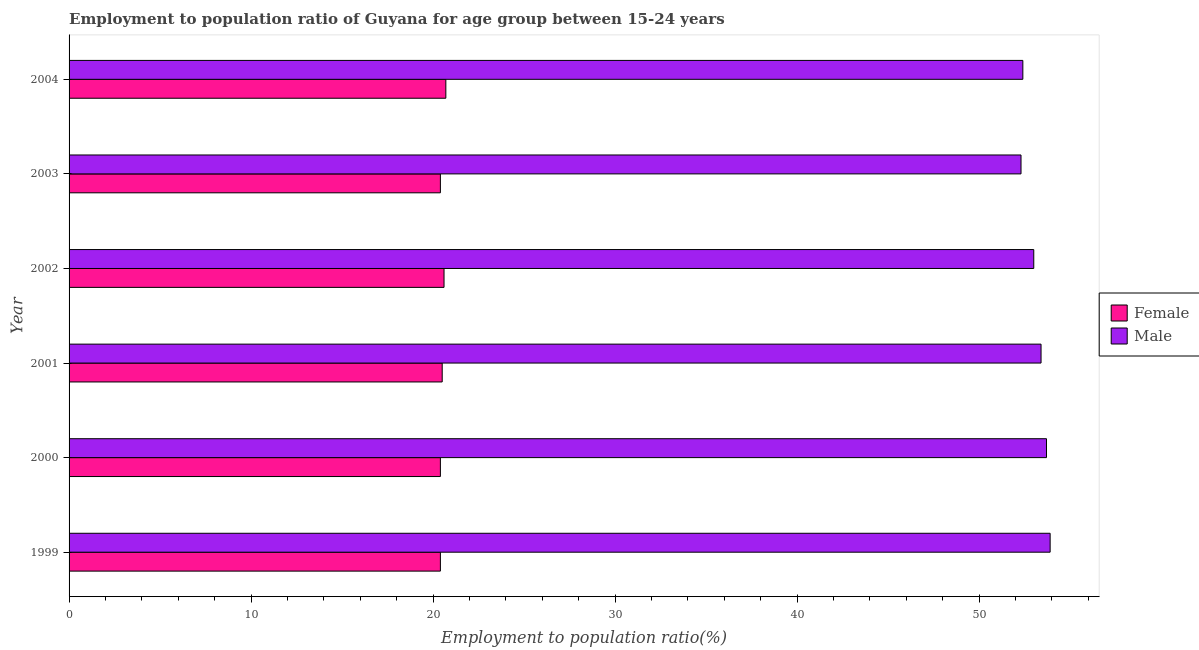Are the number of bars per tick equal to the number of legend labels?
Offer a very short reply. Yes. How many bars are there on the 3rd tick from the top?
Make the answer very short. 2. How many bars are there on the 1st tick from the bottom?
Your answer should be compact. 2. What is the label of the 1st group of bars from the top?
Offer a very short reply. 2004. In how many cases, is the number of bars for a given year not equal to the number of legend labels?
Offer a terse response. 0. What is the employment to population ratio(male) in 2002?
Your answer should be compact. 53. Across all years, what is the maximum employment to population ratio(male)?
Your answer should be very brief. 53.9. Across all years, what is the minimum employment to population ratio(female)?
Your answer should be compact. 20.4. In which year was the employment to population ratio(male) maximum?
Make the answer very short. 1999. What is the total employment to population ratio(male) in the graph?
Ensure brevity in your answer.  318.7. What is the difference between the employment to population ratio(female) in 1999 and that in 2002?
Your answer should be compact. -0.2. What is the difference between the employment to population ratio(female) in 1999 and the employment to population ratio(male) in 2001?
Your response must be concise. -33. What is the average employment to population ratio(female) per year?
Provide a short and direct response. 20.5. In the year 2004, what is the difference between the employment to population ratio(male) and employment to population ratio(female)?
Your response must be concise. 31.7. What is the ratio of the employment to population ratio(male) in 2003 to that in 2004?
Give a very brief answer. 1. Is the employment to population ratio(female) in 2000 less than that in 2001?
Offer a very short reply. Yes. Is the difference between the employment to population ratio(female) in 2001 and 2004 greater than the difference between the employment to population ratio(male) in 2001 and 2004?
Your answer should be compact. No. What is the difference between the highest and the lowest employment to population ratio(male)?
Your response must be concise. 1.6. In how many years, is the employment to population ratio(male) greater than the average employment to population ratio(male) taken over all years?
Keep it short and to the point. 3. What does the 1st bar from the bottom in 2002 represents?
Your response must be concise. Female. Are all the bars in the graph horizontal?
Offer a terse response. Yes. How many years are there in the graph?
Your answer should be compact. 6. Are the values on the major ticks of X-axis written in scientific E-notation?
Offer a very short reply. No. Does the graph contain grids?
Offer a very short reply. No. Where does the legend appear in the graph?
Make the answer very short. Center right. How many legend labels are there?
Your answer should be compact. 2. How are the legend labels stacked?
Make the answer very short. Vertical. What is the title of the graph?
Make the answer very short. Employment to population ratio of Guyana for age group between 15-24 years. What is the label or title of the X-axis?
Give a very brief answer. Employment to population ratio(%). What is the label or title of the Y-axis?
Your answer should be compact. Year. What is the Employment to population ratio(%) in Female in 1999?
Give a very brief answer. 20.4. What is the Employment to population ratio(%) in Male in 1999?
Keep it short and to the point. 53.9. What is the Employment to population ratio(%) of Female in 2000?
Your response must be concise. 20.4. What is the Employment to population ratio(%) of Male in 2000?
Your answer should be compact. 53.7. What is the Employment to population ratio(%) of Male in 2001?
Give a very brief answer. 53.4. What is the Employment to population ratio(%) in Female in 2002?
Keep it short and to the point. 20.6. What is the Employment to population ratio(%) in Male in 2002?
Provide a succinct answer. 53. What is the Employment to population ratio(%) of Female in 2003?
Make the answer very short. 20.4. What is the Employment to population ratio(%) of Male in 2003?
Make the answer very short. 52.3. What is the Employment to population ratio(%) in Female in 2004?
Provide a short and direct response. 20.7. What is the Employment to population ratio(%) in Male in 2004?
Your response must be concise. 52.4. Across all years, what is the maximum Employment to population ratio(%) in Female?
Offer a terse response. 20.7. Across all years, what is the maximum Employment to population ratio(%) of Male?
Ensure brevity in your answer.  53.9. Across all years, what is the minimum Employment to population ratio(%) in Female?
Your answer should be compact. 20.4. Across all years, what is the minimum Employment to population ratio(%) in Male?
Make the answer very short. 52.3. What is the total Employment to population ratio(%) in Female in the graph?
Your answer should be very brief. 123. What is the total Employment to population ratio(%) of Male in the graph?
Offer a very short reply. 318.7. What is the difference between the Employment to population ratio(%) in Female in 1999 and that in 2000?
Give a very brief answer. 0. What is the difference between the Employment to population ratio(%) of Female in 1999 and that in 2001?
Make the answer very short. -0.1. What is the difference between the Employment to population ratio(%) in Male in 1999 and that in 2001?
Offer a terse response. 0.5. What is the difference between the Employment to population ratio(%) in Male in 1999 and that in 2002?
Give a very brief answer. 0.9. What is the difference between the Employment to population ratio(%) of Female in 1999 and that in 2003?
Offer a very short reply. 0. What is the difference between the Employment to population ratio(%) in Male in 1999 and that in 2004?
Provide a succinct answer. 1.5. What is the difference between the Employment to population ratio(%) of Female in 2000 and that in 2001?
Ensure brevity in your answer.  -0.1. What is the difference between the Employment to population ratio(%) in Male in 2000 and that in 2002?
Keep it short and to the point. 0.7. What is the difference between the Employment to population ratio(%) of Female in 2000 and that in 2003?
Provide a succinct answer. 0. What is the difference between the Employment to population ratio(%) in Female in 2000 and that in 2004?
Offer a very short reply. -0.3. What is the difference between the Employment to population ratio(%) of Male in 2001 and that in 2002?
Make the answer very short. 0.4. What is the difference between the Employment to population ratio(%) of Male in 2001 and that in 2003?
Offer a terse response. 1.1. What is the difference between the Employment to population ratio(%) in Female in 2001 and that in 2004?
Your response must be concise. -0.2. What is the difference between the Employment to population ratio(%) in Male in 2001 and that in 2004?
Give a very brief answer. 1. What is the difference between the Employment to population ratio(%) of Female in 2002 and that in 2003?
Your answer should be compact. 0.2. What is the difference between the Employment to population ratio(%) in Male in 2002 and that in 2003?
Ensure brevity in your answer.  0.7. What is the difference between the Employment to population ratio(%) in Male in 2002 and that in 2004?
Provide a short and direct response. 0.6. What is the difference between the Employment to population ratio(%) in Female in 2003 and that in 2004?
Make the answer very short. -0.3. What is the difference between the Employment to population ratio(%) in Female in 1999 and the Employment to population ratio(%) in Male in 2000?
Offer a very short reply. -33.3. What is the difference between the Employment to population ratio(%) in Female in 1999 and the Employment to population ratio(%) in Male in 2001?
Your answer should be compact. -33. What is the difference between the Employment to population ratio(%) in Female in 1999 and the Employment to population ratio(%) in Male in 2002?
Give a very brief answer. -32.6. What is the difference between the Employment to population ratio(%) in Female in 1999 and the Employment to population ratio(%) in Male in 2003?
Provide a succinct answer. -31.9. What is the difference between the Employment to population ratio(%) in Female in 1999 and the Employment to population ratio(%) in Male in 2004?
Make the answer very short. -32. What is the difference between the Employment to population ratio(%) in Female in 2000 and the Employment to population ratio(%) in Male in 2001?
Ensure brevity in your answer.  -33. What is the difference between the Employment to population ratio(%) of Female in 2000 and the Employment to population ratio(%) of Male in 2002?
Ensure brevity in your answer.  -32.6. What is the difference between the Employment to population ratio(%) in Female in 2000 and the Employment to population ratio(%) in Male in 2003?
Offer a very short reply. -31.9. What is the difference between the Employment to population ratio(%) in Female in 2000 and the Employment to population ratio(%) in Male in 2004?
Ensure brevity in your answer.  -32. What is the difference between the Employment to population ratio(%) in Female in 2001 and the Employment to population ratio(%) in Male in 2002?
Keep it short and to the point. -32.5. What is the difference between the Employment to population ratio(%) of Female in 2001 and the Employment to population ratio(%) of Male in 2003?
Keep it short and to the point. -31.8. What is the difference between the Employment to population ratio(%) in Female in 2001 and the Employment to population ratio(%) in Male in 2004?
Provide a succinct answer. -31.9. What is the difference between the Employment to population ratio(%) in Female in 2002 and the Employment to population ratio(%) in Male in 2003?
Your answer should be very brief. -31.7. What is the difference between the Employment to population ratio(%) in Female in 2002 and the Employment to population ratio(%) in Male in 2004?
Your answer should be compact. -31.8. What is the difference between the Employment to population ratio(%) of Female in 2003 and the Employment to population ratio(%) of Male in 2004?
Your answer should be compact. -32. What is the average Employment to population ratio(%) in Female per year?
Ensure brevity in your answer.  20.5. What is the average Employment to population ratio(%) of Male per year?
Ensure brevity in your answer.  53.12. In the year 1999, what is the difference between the Employment to population ratio(%) of Female and Employment to population ratio(%) of Male?
Your answer should be compact. -33.5. In the year 2000, what is the difference between the Employment to population ratio(%) of Female and Employment to population ratio(%) of Male?
Offer a terse response. -33.3. In the year 2001, what is the difference between the Employment to population ratio(%) in Female and Employment to population ratio(%) in Male?
Offer a very short reply. -32.9. In the year 2002, what is the difference between the Employment to population ratio(%) of Female and Employment to population ratio(%) of Male?
Your answer should be compact. -32.4. In the year 2003, what is the difference between the Employment to population ratio(%) in Female and Employment to population ratio(%) in Male?
Your response must be concise. -31.9. In the year 2004, what is the difference between the Employment to population ratio(%) in Female and Employment to population ratio(%) in Male?
Make the answer very short. -31.7. What is the ratio of the Employment to population ratio(%) in Male in 1999 to that in 2000?
Give a very brief answer. 1. What is the ratio of the Employment to population ratio(%) in Female in 1999 to that in 2001?
Ensure brevity in your answer.  1. What is the ratio of the Employment to population ratio(%) in Male in 1999 to that in 2001?
Your answer should be very brief. 1.01. What is the ratio of the Employment to population ratio(%) of Female in 1999 to that in 2002?
Offer a very short reply. 0.99. What is the ratio of the Employment to population ratio(%) of Male in 1999 to that in 2002?
Provide a succinct answer. 1.02. What is the ratio of the Employment to population ratio(%) in Female in 1999 to that in 2003?
Ensure brevity in your answer.  1. What is the ratio of the Employment to population ratio(%) of Male in 1999 to that in 2003?
Your answer should be very brief. 1.03. What is the ratio of the Employment to population ratio(%) of Female in 1999 to that in 2004?
Give a very brief answer. 0.99. What is the ratio of the Employment to population ratio(%) of Male in 1999 to that in 2004?
Offer a very short reply. 1.03. What is the ratio of the Employment to population ratio(%) in Male in 2000 to that in 2001?
Offer a very short reply. 1.01. What is the ratio of the Employment to population ratio(%) of Female in 2000 to that in 2002?
Provide a succinct answer. 0.99. What is the ratio of the Employment to population ratio(%) in Male in 2000 to that in 2002?
Offer a terse response. 1.01. What is the ratio of the Employment to population ratio(%) of Female in 2000 to that in 2003?
Your answer should be compact. 1. What is the ratio of the Employment to population ratio(%) of Male in 2000 to that in 2003?
Your answer should be very brief. 1.03. What is the ratio of the Employment to population ratio(%) in Female in 2000 to that in 2004?
Keep it short and to the point. 0.99. What is the ratio of the Employment to population ratio(%) of Male in 2000 to that in 2004?
Ensure brevity in your answer.  1.02. What is the ratio of the Employment to population ratio(%) of Female in 2001 to that in 2002?
Your response must be concise. 1. What is the ratio of the Employment to population ratio(%) in Male in 2001 to that in 2002?
Make the answer very short. 1.01. What is the ratio of the Employment to population ratio(%) in Female in 2001 to that in 2003?
Your response must be concise. 1. What is the ratio of the Employment to population ratio(%) of Male in 2001 to that in 2003?
Offer a terse response. 1.02. What is the ratio of the Employment to population ratio(%) in Female in 2001 to that in 2004?
Provide a short and direct response. 0.99. What is the ratio of the Employment to population ratio(%) of Male in 2001 to that in 2004?
Provide a short and direct response. 1.02. What is the ratio of the Employment to population ratio(%) in Female in 2002 to that in 2003?
Ensure brevity in your answer.  1.01. What is the ratio of the Employment to population ratio(%) in Male in 2002 to that in 2003?
Give a very brief answer. 1.01. What is the ratio of the Employment to population ratio(%) in Male in 2002 to that in 2004?
Make the answer very short. 1.01. What is the ratio of the Employment to population ratio(%) of Female in 2003 to that in 2004?
Your answer should be compact. 0.99. What is the ratio of the Employment to population ratio(%) in Male in 2003 to that in 2004?
Make the answer very short. 1. What is the difference between the highest and the lowest Employment to population ratio(%) in Male?
Your response must be concise. 1.6. 